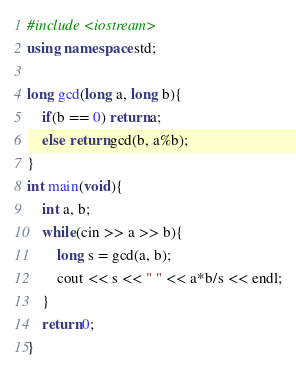<code> <loc_0><loc_0><loc_500><loc_500><_C++_>#include <iostream>
using namespace std;

long gcd(long a, long b){
    if(b == 0) return a;
    else return gcd(b, a%b);
}
int main(void){
    int a, b;
    while(cin >> a >> b){
        long s = gcd(a, b);
        cout << s << " " << a*b/s << endl;
    }
    return 0;
}

</code> 